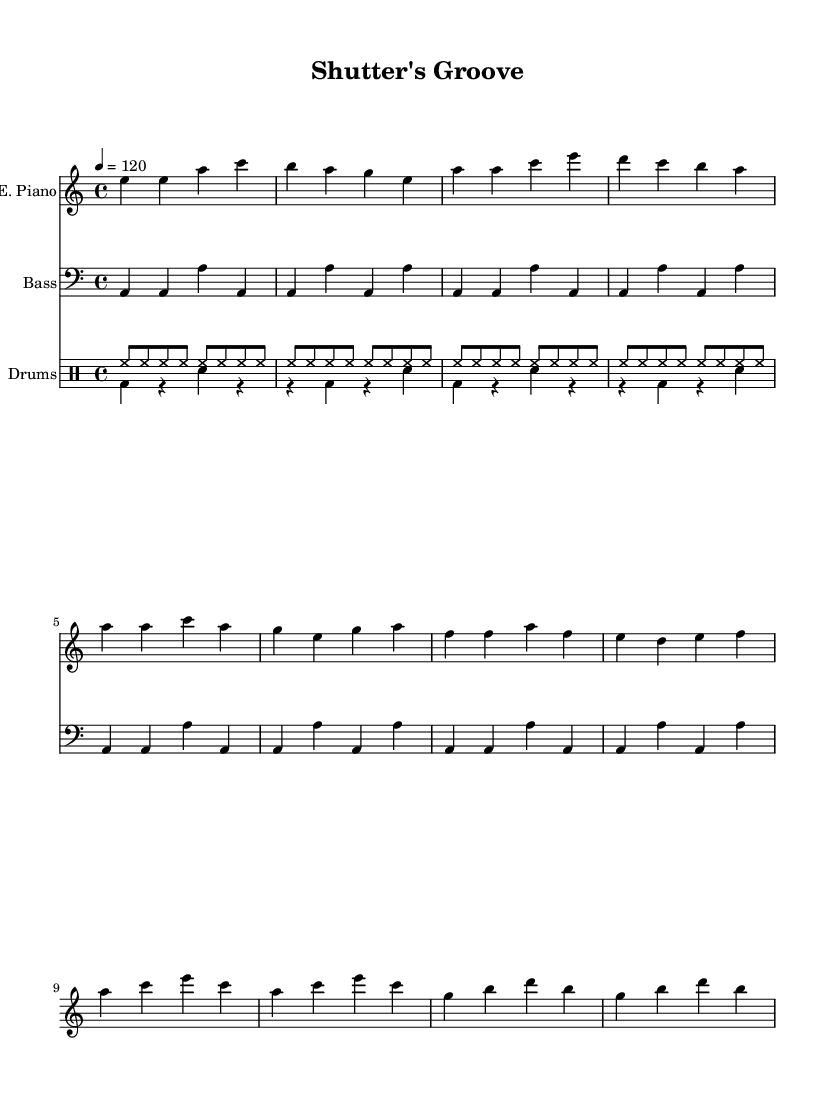What is the key signature of this music? The key signature is A minor, indicated by the absence of sharps or flats on the staff. A minor has the same key signature as C major.
Answer: A minor What is the time signature? The time signature is 4/4, which is commonly used in disco music. It is indicated at the beginning of the staff.
Answer: 4/4 What is the tempo marking? The tempo marking is quarter note equals 120, which indicates the speed of the music. This number tells musicians to play 120 beats per minute.
Answer: 120 How many measures are there in the introduction? The introduction consists of 4 measures, as can be counted from the beginning of the electric piano part up to the end of the specified section.
Answer: 4 What instruments are featured in this piece? The piece features an electric piano, bass guitar, and drums. Each is written on a separate staff in the score.
Answer: Electric piano, bass, drums What rhythmic pattern is used in the drum part? The drum part features a combination of hi-hats played in eighth notes and bass drums and snares played in quarter notes, typical of disco rhythms.
Answer: Hi-hat and bass/snares What is the structure of the verse section? The verse section is structured in a concise repeating pattern that alternates between specific notes and creates a melodic line, as indicated in the electric piano staff.
Answer: Abbreviated repeating pattern 